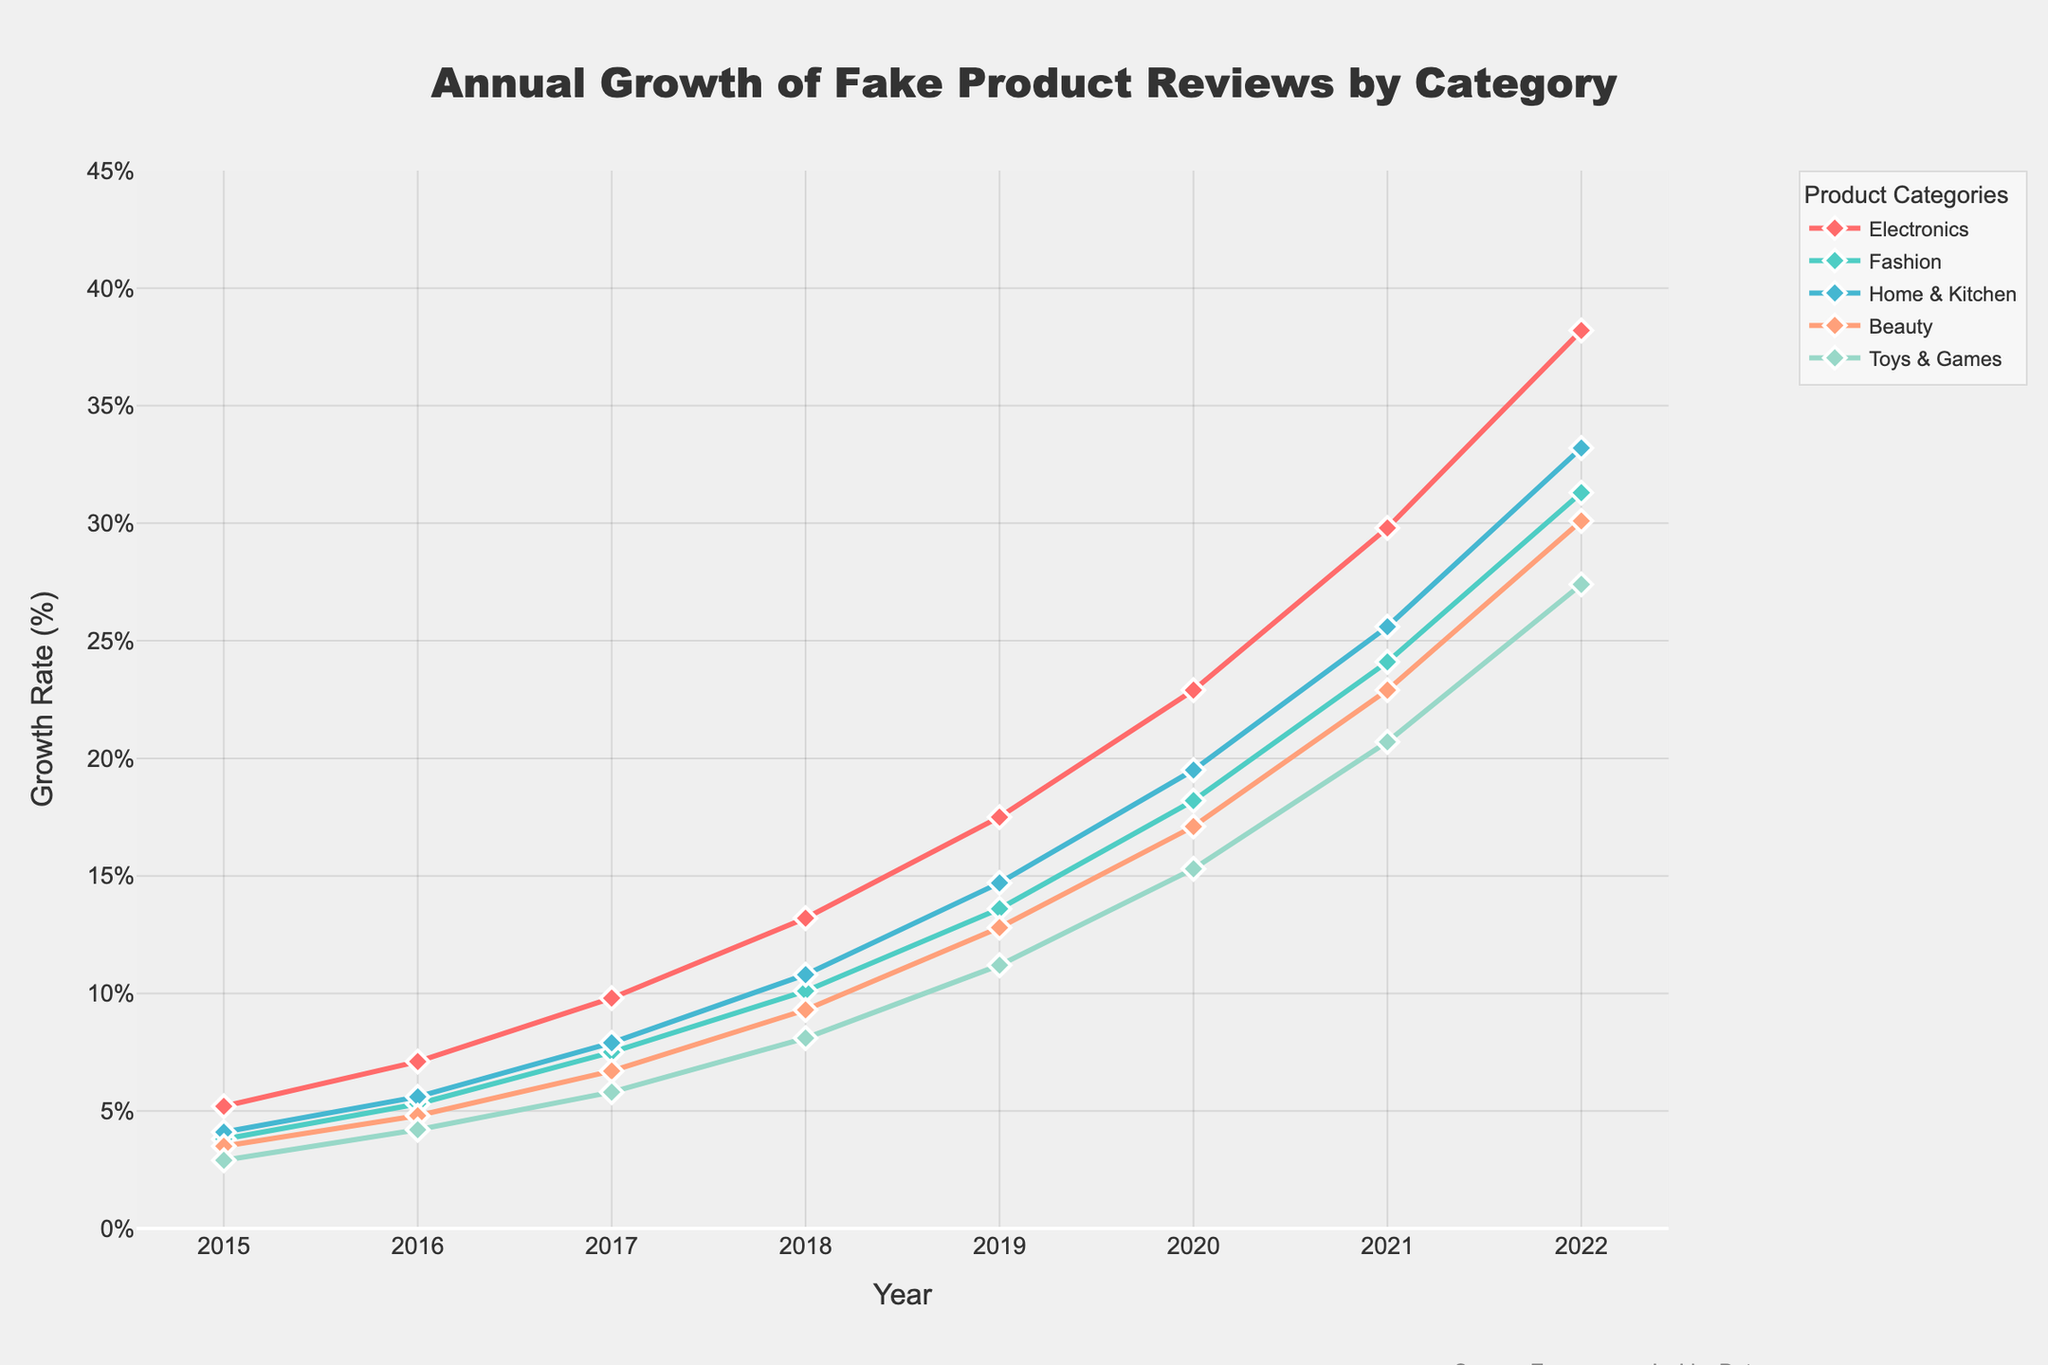what was the growth rate for "Beauty" products in 2018 Look at the line labeled "Beauty" and find the value at the point for the year 2018, which is the intersection of the "Beauty" line and the year 2018 on the x-axis.
Answer: 9.3% which product category had the highest growth in fake reviews in 2022 Look for the highest point on the y-axis for the year 2022 among all the product category lines. The line for "Electronics" reaches the highest value in 2022.
Answer: Electronics how much did the growth rate for "Fashion" products increase from 2016 to 2020 Subtract the growth rate for "Fashion" in 2016 from its rate in 2020: 18.2 - 5.3 = 12.9.
Answer: 12.9 compare the growth rates of "Toys & Games" and "Home & Kitchen" in 2017 Look at the points for both "Toys & Games" and "Home & Kitchen" in 2017. "Toys & Games" is at 5.8% and "Home & Kitchen" is at 7.9%. "Home & Kitchen" is higher.
Answer: Home & Kitchen what is the average growth rate for "Home & Kitchen" from 2015 to 2018 Add the values for "Home & Kitchen" from 2015 to 2018 (4.1 + 5.6 + 7.9 + 10.8), then divide by the number of years (4): (4.1 + 5.6 + 7.9 + 10.8) / 4 = 7.1.
Answer: 7.1 which product category had the lowest growth rate in 2015 Find the lowest point on the graph for the year 2015. The line for "Toys & Games" is at the lowest value in 2015.
Answer: Toys & Games what year did the "Electronics" category see the largest year-on-year increase Compare the year-on-year increase for "Electronics" by subtracting the previous year's value from the current year for each year and identify the largest difference. From the data: 1.9 (2016-2015), 2.7 (2017-2016), 3.4 (2018-2017), 4.3 (2019-2018), 5.4 (2020-2019), 6.9 (2021-2020), 8.4 (2022-2021). The largest increase occurs between 2021 and 2022.
Answer: 2022 is there any year where "Beauty" has a higher growth rate than "Electronics" Compare the points for "Beauty" and "Electronics" for each year. The "Electronics" category always has a higher growth rate than "Beauty" in each year.
Answer: No what was the combined growth rate of all categories in 2015 Add the growth rates for all the categories in 2015: 5.2 + 3.8 + 4.1 + 3.5 + 2.9 = 19.5.
Answer: 19.5 which category had a greater increase in growth rate from 2019 to 2020, "Fashion" or "Toys & Games" Calculate the increase for both categories: "Fashion" (18.2 - 13.6 = 4.6), "Toys & Games" (15.3 - 11.2 = 4.1). "Fashion" has a greater increase.
Answer: Fashion 